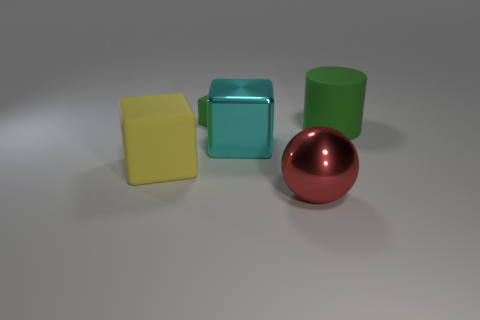Subtract all big matte cubes. How many cubes are left? 2 Add 5 large yellow blocks. How many objects exist? 10 Subtract all blue cubes. Subtract all brown balls. How many cubes are left? 3 Subtract all cubes. How many objects are left? 2 Add 1 rubber objects. How many rubber objects are left? 4 Add 4 large matte blocks. How many large matte blocks exist? 5 Subtract 1 red spheres. How many objects are left? 4 Subtract all large shiny things. Subtract all big cyan metallic objects. How many objects are left? 2 